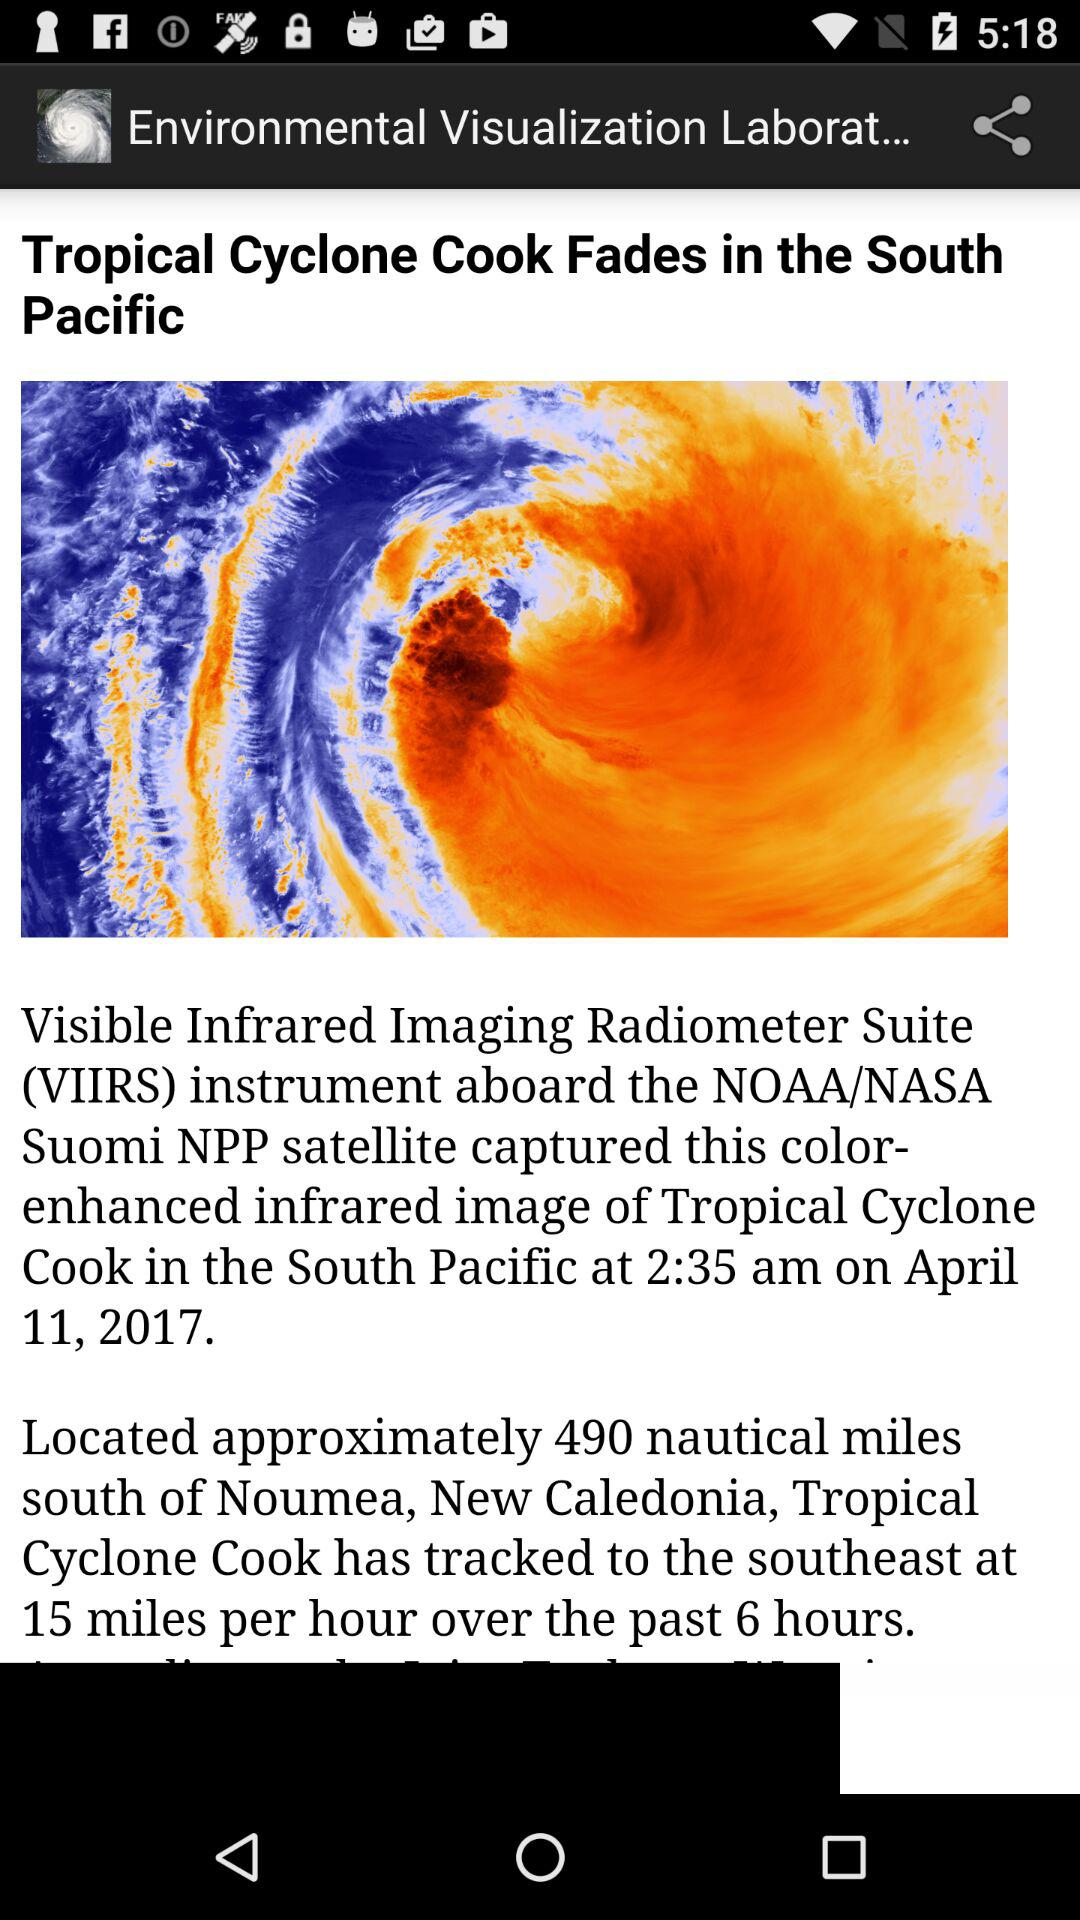What is the full form of VIIRS? The full form is Visible Infrared Imaging Radiometer Suite. 